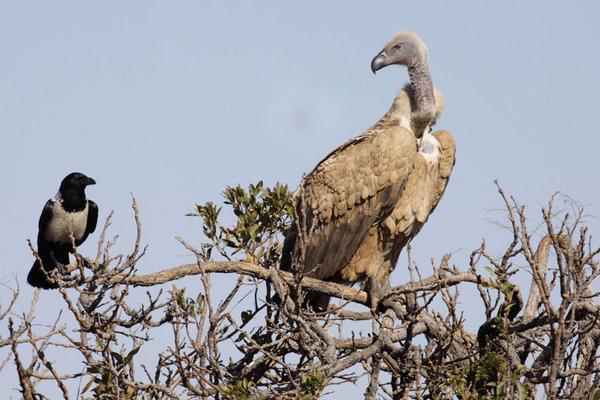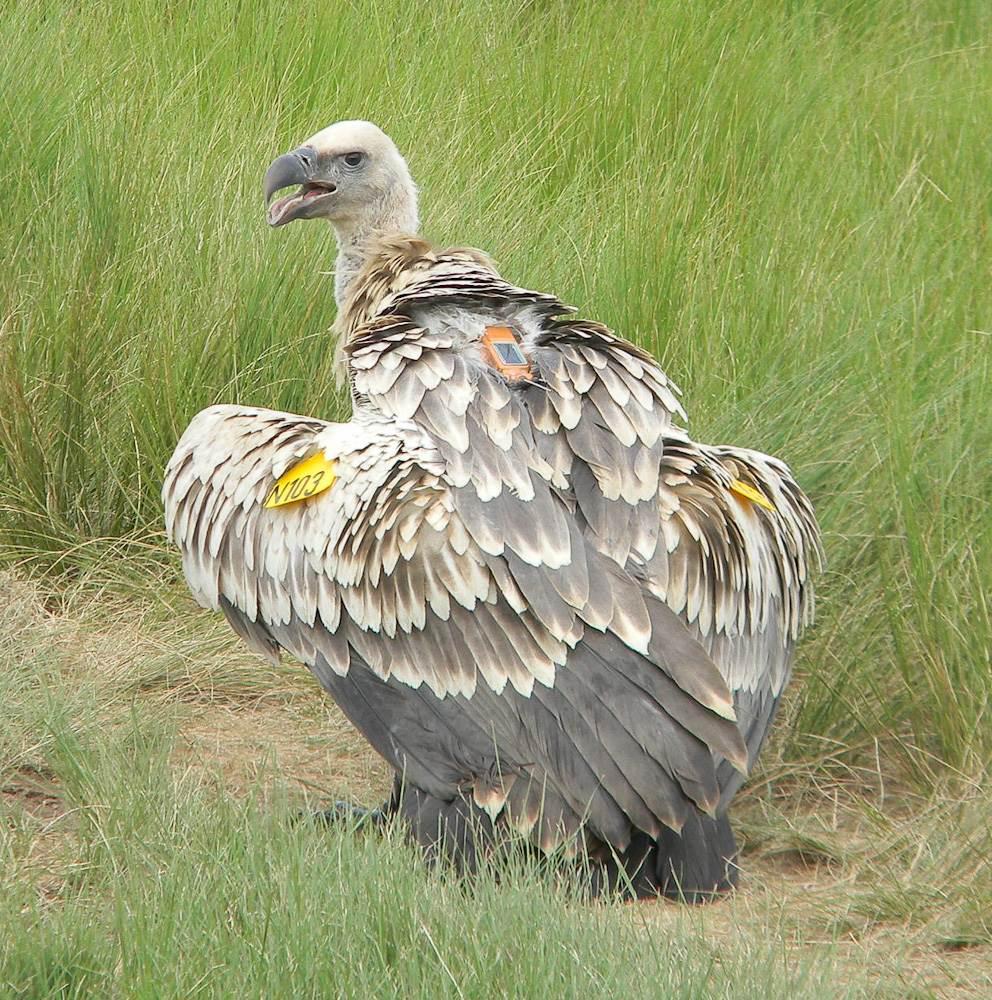The first image is the image on the left, the second image is the image on the right. Assess this claim about the two images: "There is at least one bird sitting on a branch in each picture.". Correct or not? Answer yes or no. No. 